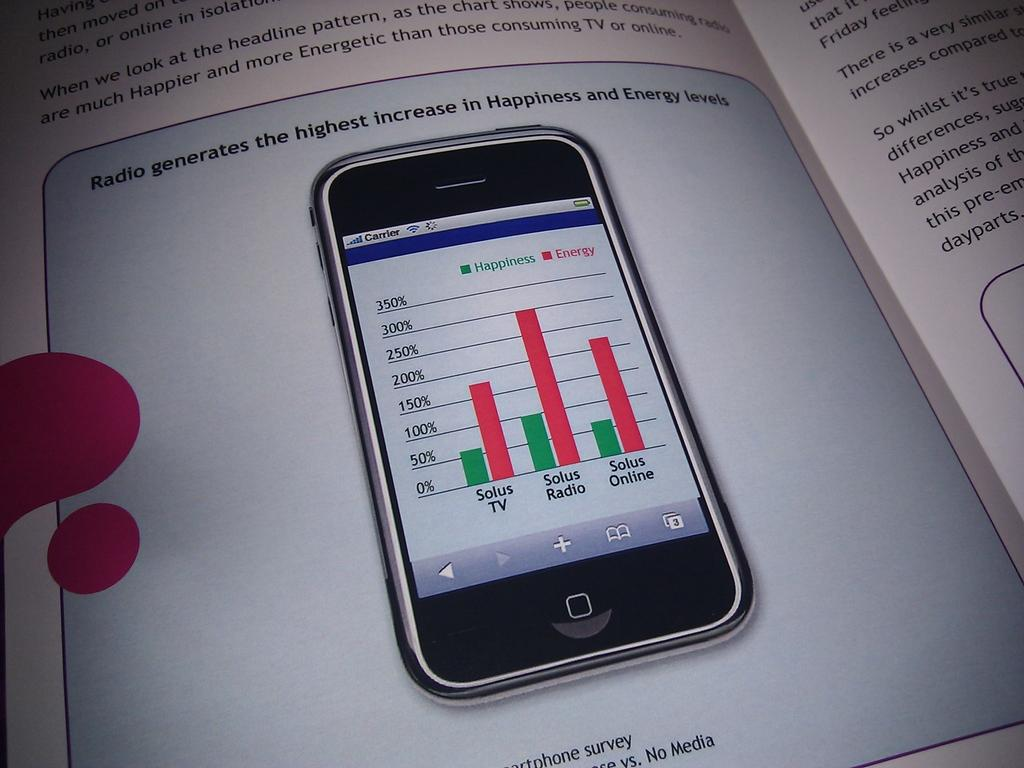<image>
Offer a succinct explanation of the picture presented. an open book with a picture of a cell phone that shows happiness and energy scales. 